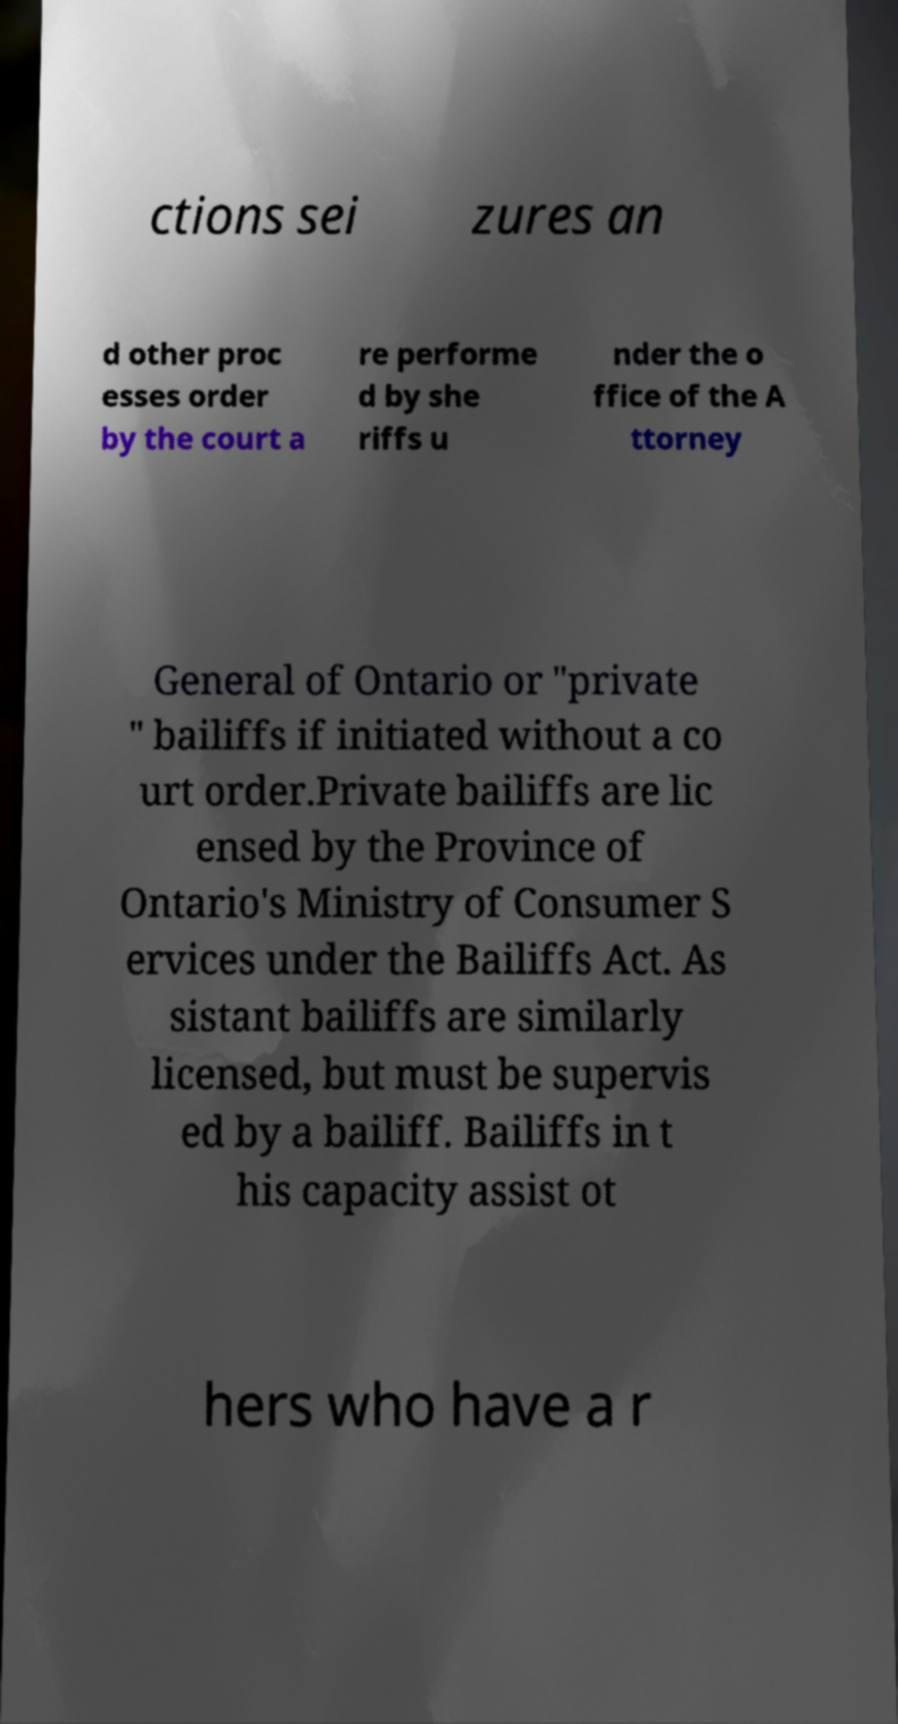Please read and relay the text visible in this image. What does it say? ctions sei zures an d other proc esses order by the court a re performe d by she riffs u nder the o ffice of the A ttorney General of Ontario or "private " bailiffs if initiated without a co urt order.Private bailiffs are lic ensed by the Province of Ontario's Ministry of Consumer S ervices under the Bailiffs Act. As sistant bailiffs are similarly licensed, but must be supervis ed by a bailiff. Bailiffs in t his capacity assist ot hers who have a r 